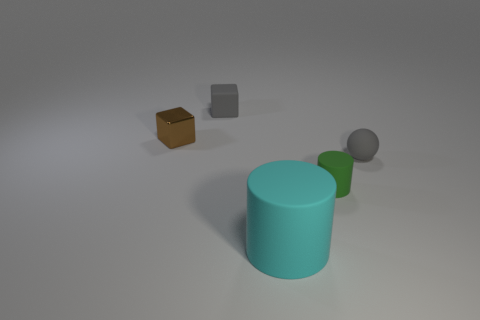Add 1 cylinders. How many objects exist? 6 Subtract all balls. How many objects are left? 4 Subtract all large cyan matte balls. Subtract all gray blocks. How many objects are left? 4 Add 2 big matte objects. How many big matte objects are left? 3 Add 2 gray balls. How many gray balls exist? 3 Subtract 0 cyan blocks. How many objects are left? 5 